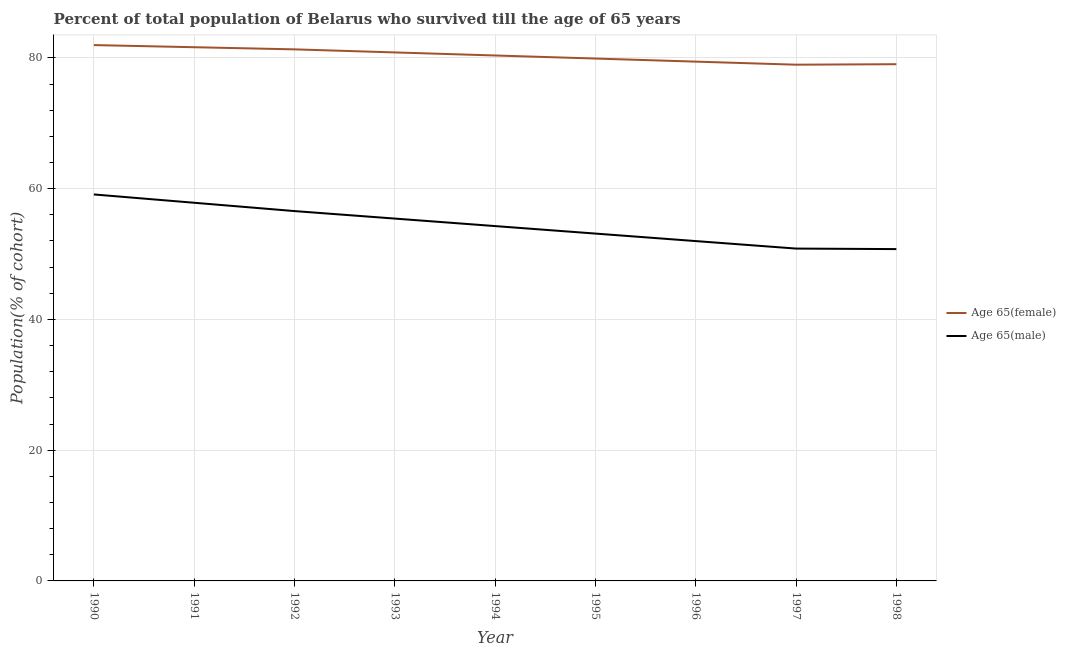How many different coloured lines are there?
Offer a terse response. 2. Does the line corresponding to percentage of female population who survived till age of 65 intersect with the line corresponding to percentage of male population who survived till age of 65?
Make the answer very short. No. Is the number of lines equal to the number of legend labels?
Offer a very short reply. Yes. What is the percentage of female population who survived till age of 65 in 1995?
Give a very brief answer. 79.9. Across all years, what is the maximum percentage of female population who survived till age of 65?
Keep it short and to the point. 81.96. Across all years, what is the minimum percentage of female population who survived till age of 65?
Offer a very short reply. 78.96. What is the total percentage of male population who survived till age of 65 in the graph?
Ensure brevity in your answer.  489.93. What is the difference between the percentage of female population who survived till age of 65 in 1995 and that in 1996?
Give a very brief answer. 0.47. What is the difference between the percentage of female population who survived till age of 65 in 1992 and the percentage of male population who survived till age of 65 in 1998?
Make the answer very short. 30.55. What is the average percentage of male population who survived till age of 65 per year?
Ensure brevity in your answer.  54.44. In the year 1996, what is the difference between the percentage of female population who survived till age of 65 and percentage of male population who survived till age of 65?
Offer a terse response. 27.45. In how many years, is the percentage of male population who survived till age of 65 greater than 24 %?
Provide a succinct answer. 9. What is the ratio of the percentage of female population who survived till age of 65 in 1995 to that in 1996?
Your answer should be very brief. 1.01. Is the percentage of female population who survived till age of 65 in 1995 less than that in 1997?
Your answer should be very brief. No. Is the difference between the percentage of female population who survived till age of 65 in 1993 and 1995 greater than the difference between the percentage of male population who survived till age of 65 in 1993 and 1995?
Keep it short and to the point. No. What is the difference between the highest and the second highest percentage of male population who survived till age of 65?
Provide a short and direct response. 1.27. What is the difference between the highest and the lowest percentage of male population who survived till age of 65?
Make the answer very short. 8.36. In how many years, is the percentage of female population who survived till age of 65 greater than the average percentage of female population who survived till age of 65 taken over all years?
Provide a succinct answer. 4. Does the graph contain grids?
Provide a short and direct response. Yes. What is the title of the graph?
Offer a terse response. Percent of total population of Belarus who survived till the age of 65 years. What is the label or title of the Y-axis?
Offer a very short reply. Population(% of cohort). What is the Population(% of cohort) in Age 65(female) in 1990?
Your response must be concise. 81.96. What is the Population(% of cohort) of Age 65(male) in 1990?
Your answer should be very brief. 59.11. What is the Population(% of cohort) of Age 65(female) in 1991?
Keep it short and to the point. 81.63. What is the Population(% of cohort) of Age 65(male) in 1991?
Provide a short and direct response. 57.84. What is the Population(% of cohort) of Age 65(female) in 1992?
Your response must be concise. 81.31. What is the Population(% of cohort) in Age 65(male) in 1992?
Offer a very short reply. 56.57. What is the Population(% of cohort) of Age 65(female) in 1993?
Ensure brevity in your answer.  80.84. What is the Population(% of cohort) of Age 65(male) in 1993?
Offer a very short reply. 55.42. What is the Population(% of cohort) in Age 65(female) in 1994?
Offer a terse response. 80.37. What is the Population(% of cohort) in Age 65(male) in 1994?
Your response must be concise. 54.28. What is the Population(% of cohort) of Age 65(female) in 1995?
Offer a very short reply. 79.9. What is the Population(% of cohort) of Age 65(male) in 1995?
Keep it short and to the point. 53.13. What is the Population(% of cohort) of Age 65(female) in 1996?
Ensure brevity in your answer.  79.43. What is the Population(% of cohort) in Age 65(male) in 1996?
Offer a very short reply. 51.98. What is the Population(% of cohort) in Age 65(female) in 1997?
Provide a short and direct response. 78.96. What is the Population(% of cohort) of Age 65(male) in 1997?
Your response must be concise. 50.83. What is the Population(% of cohort) of Age 65(female) in 1998?
Your answer should be very brief. 79.04. What is the Population(% of cohort) in Age 65(male) in 1998?
Ensure brevity in your answer.  50.76. Across all years, what is the maximum Population(% of cohort) in Age 65(female)?
Ensure brevity in your answer.  81.96. Across all years, what is the maximum Population(% of cohort) of Age 65(male)?
Provide a succinct answer. 59.11. Across all years, what is the minimum Population(% of cohort) of Age 65(female)?
Ensure brevity in your answer.  78.96. Across all years, what is the minimum Population(% of cohort) of Age 65(male)?
Provide a succinct answer. 50.76. What is the total Population(% of cohort) of Age 65(female) in the graph?
Offer a terse response. 723.43. What is the total Population(% of cohort) in Age 65(male) in the graph?
Offer a very short reply. 489.93. What is the difference between the Population(% of cohort) in Age 65(female) in 1990 and that in 1991?
Give a very brief answer. 0.33. What is the difference between the Population(% of cohort) in Age 65(male) in 1990 and that in 1991?
Keep it short and to the point. 1.27. What is the difference between the Population(% of cohort) in Age 65(female) in 1990 and that in 1992?
Your response must be concise. 0.65. What is the difference between the Population(% of cohort) in Age 65(male) in 1990 and that in 1992?
Your answer should be very brief. 2.54. What is the difference between the Population(% of cohort) in Age 65(female) in 1990 and that in 1993?
Make the answer very short. 1.12. What is the difference between the Population(% of cohort) in Age 65(male) in 1990 and that in 1993?
Your answer should be compact. 3.69. What is the difference between the Population(% of cohort) of Age 65(female) in 1990 and that in 1994?
Provide a short and direct response. 1.59. What is the difference between the Population(% of cohort) of Age 65(male) in 1990 and that in 1994?
Provide a succinct answer. 4.84. What is the difference between the Population(% of cohort) in Age 65(female) in 1990 and that in 1995?
Provide a succinct answer. 2.06. What is the difference between the Population(% of cohort) in Age 65(male) in 1990 and that in 1995?
Provide a short and direct response. 5.99. What is the difference between the Population(% of cohort) in Age 65(female) in 1990 and that in 1996?
Provide a short and direct response. 2.53. What is the difference between the Population(% of cohort) of Age 65(male) in 1990 and that in 1996?
Keep it short and to the point. 7.13. What is the difference between the Population(% of cohort) of Age 65(female) in 1990 and that in 1997?
Give a very brief answer. 3. What is the difference between the Population(% of cohort) of Age 65(male) in 1990 and that in 1997?
Your answer should be very brief. 8.28. What is the difference between the Population(% of cohort) in Age 65(female) in 1990 and that in 1998?
Provide a short and direct response. 2.93. What is the difference between the Population(% of cohort) in Age 65(male) in 1990 and that in 1998?
Offer a very short reply. 8.36. What is the difference between the Population(% of cohort) in Age 65(female) in 1991 and that in 1992?
Provide a succinct answer. 0.33. What is the difference between the Population(% of cohort) of Age 65(male) in 1991 and that in 1992?
Offer a terse response. 1.27. What is the difference between the Population(% of cohort) in Age 65(female) in 1991 and that in 1993?
Make the answer very short. 0.8. What is the difference between the Population(% of cohort) of Age 65(male) in 1991 and that in 1993?
Provide a succinct answer. 2.42. What is the difference between the Population(% of cohort) in Age 65(female) in 1991 and that in 1994?
Your response must be concise. 1.27. What is the difference between the Population(% of cohort) in Age 65(male) in 1991 and that in 1994?
Ensure brevity in your answer.  3.57. What is the difference between the Population(% of cohort) in Age 65(female) in 1991 and that in 1995?
Keep it short and to the point. 1.73. What is the difference between the Population(% of cohort) in Age 65(male) in 1991 and that in 1995?
Provide a succinct answer. 4.71. What is the difference between the Population(% of cohort) of Age 65(female) in 1991 and that in 1996?
Provide a succinct answer. 2.2. What is the difference between the Population(% of cohort) in Age 65(male) in 1991 and that in 1996?
Your response must be concise. 5.86. What is the difference between the Population(% of cohort) in Age 65(female) in 1991 and that in 1997?
Ensure brevity in your answer.  2.67. What is the difference between the Population(% of cohort) of Age 65(male) in 1991 and that in 1997?
Give a very brief answer. 7.01. What is the difference between the Population(% of cohort) in Age 65(female) in 1991 and that in 1998?
Give a very brief answer. 2.6. What is the difference between the Population(% of cohort) in Age 65(male) in 1991 and that in 1998?
Your response must be concise. 7.09. What is the difference between the Population(% of cohort) of Age 65(female) in 1992 and that in 1993?
Offer a very short reply. 0.47. What is the difference between the Population(% of cohort) of Age 65(male) in 1992 and that in 1993?
Offer a very short reply. 1.15. What is the difference between the Population(% of cohort) of Age 65(female) in 1992 and that in 1994?
Offer a very short reply. 0.94. What is the difference between the Population(% of cohort) in Age 65(male) in 1992 and that in 1994?
Ensure brevity in your answer.  2.29. What is the difference between the Population(% of cohort) of Age 65(female) in 1992 and that in 1995?
Give a very brief answer. 1.41. What is the difference between the Population(% of cohort) in Age 65(male) in 1992 and that in 1995?
Provide a short and direct response. 3.44. What is the difference between the Population(% of cohort) in Age 65(female) in 1992 and that in 1996?
Your answer should be compact. 1.88. What is the difference between the Population(% of cohort) of Age 65(male) in 1992 and that in 1996?
Give a very brief answer. 4.59. What is the difference between the Population(% of cohort) of Age 65(female) in 1992 and that in 1997?
Provide a short and direct response. 2.34. What is the difference between the Population(% of cohort) in Age 65(male) in 1992 and that in 1997?
Provide a short and direct response. 5.74. What is the difference between the Population(% of cohort) in Age 65(female) in 1992 and that in 1998?
Give a very brief answer. 2.27. What is the difference between the Population(% of cohort) of Age 65(male) in 1992 and that in 1998?
Ensure brevity in your answer.  5.81. What is the difference between the Population(% of cohort) in Age 65(female) in 1993 and that in 1994?
Offer a very short reply. 0.47. What is the difference between the Population(% of cohort) of Age 65(male) in 1993 and that in 1994?
Your response must be concise. 1.15. What is the difference between the Population(% of cohort) of Age 65(female) in 1993 and that in 1995?
Offer a terse response. 0.94. What is the difference between the Population(% of cohort) in Age 65(male) in 1993 and that in 1995?
Keep it short and to the point. 2.29. What is the difference between the Population(% of cohort) of Age 65(female) in 1993 and that in 1996?
Provide a short and direct response. 1.41. What is the difference between the Population(% of cohort) of Age 65(male) in 1993 and that in 1996?
Your response must be concise. 3.44. What is the difference between the Population(% of cohort) in Age 65(female) in 1993 and that in 1997?
Your response must be concise. 1.88. What is the difference between the Population(% of cohort) in Age 65(male) in 1993 and that in 1997?
Your response must be concise. 4.59. What is the difference between the Population(% of cohort) of Age 65(female) in 1993 and that in 1998?
Offer a very short reply. 1.8. What is the difference between the Population(% of cohort) in Age 65(male) in 1993 and that in 1998?
Your answer should be compact. 4.67. What is the difference between the Population(% of cohort) in Age 65(female) in 1994 and that in 1995?
Provide a short and direct response. 0.47. What is the difference between the Population(% of cohort) in Age 65(male) in 1994 and that in 1995?
Your response must be concise. 1.15. What is the difference between the Population(% of cohort) of Age 65(female) in 1994 and that in 1996?
Keep it short and to the point. 0.94. What is the difference between the Population(% of cohort) of Age 65(male) in 1994 and that in 1996?
Provide a short and direct response. 2.29. What is the difference between the Population(% of cohort) in Age 65(female) in 1994 and that in 1997?
Offer a terse response. 1.41. What is the difference between the Population(% of cohort) of Age 65(male) in 1994 and that in 1997?
Provide a short and direct response. 3.44. What is the difference between the Population(% of cohort) in Age 65(female) in 1994 and that in 1998?
Give a very brief answer. 1.33. What is the difference between the Population(% of cohort) of Age 65(male) in 1994 and that in 1998?
Keep it short and to the point. 3.52. What is the difference between the Population(% of cohort) in Age 65(female) in 1995 and that in 1996?
Provide a short and direct response. 0.47. What is the difference between the Population(% of cohort) of Age 65(male) in 1995 and that in 1996?
Your answer should be compact. 1.15. What is the difference between the Population(% of cohort) in Age 65(female) in 1995 and that in 1997?
Provide a short and direct response. 0.94. What is the difference between the Population(% of cohort) of Age 65(male) in 1995 and that in 1997?
Ensure brevity in your answer.  2.29. What is the difference between the Population(% of cohort) of Age 65(female) in 1995 and that in 1998?
Give a very brief answer. 0.86. What is the difference between the Population(% of cohort) in Age 65(male) in 1995 and that in 1998?
Provide a succinct answer. 2.37. What is the difference between the Population(% of cohort) of Age 65(female) in 1996 and that in 1997?
Offer a terse response. 0.47. What is the difference between the Population(% of cohort) in Age 65(male) in 1996 and that in 1997?
Ensure brevity in your answer.  1.15. What is the difference between the Population(% of cohort) of Age 65(female) in 1996 and that in 1998?
Make the answer very short. 0.4. What is the difference between the Population(% of cohort) in Age 65(male) in 1996 and that in 1998?
Make the answer very short. 1.23. What is the difference between the Population(% of cohort) of Age 65(female) in 1997 and that in 1998?
Provide a succinct answer. -0.07. What is the difference between the Population(% of cohort) of Age 65(male) in 1997 and that in 1998?
Provide a succinct answer. 0.08. What is the difference between the Population(% of cohort) in Age 65(female) in 1990 and the Population(% of cohort) in Age 65(male) in 1991?
Offer a very short reply. 24.12. What is the difference between the Population(% of cohort) in Age 65(female) in 1990 and the Population(% of cohort) in Age 65(male) in 1992?
Ensure brevity in your answer.  25.39. What is the difference between the Population(% of cohort) of Age 65(female) in 1990 and the Population(% of cohort) of Age 65(male) in 1993?
Provide a short and direct response. 26.54. What is the difference between the Population(% of cohort) of Age 65(female) in 1990 and the Population(% of cohort) of Age 65(male) in 1994?
Offer a very short reply. 27.69. What is the difference between the Population(% of cohort) of Age 65(female) in 1990 and the Population(% of cohort) of Age 65(male) in 1995?
Offer a terse response. 28.83. What is the difference between the Population(% of cohort) in Age 65(female) in 1990 and the Population(% of cohort) in Age 65(male) in 1996?
Your answer should be compact. 29.98. What is the difference between the Population(% of cohort) in Age 65(female) in 1990 and the Population(% of cohort) in Age 65(male) in 1997?
Your response must be concise. 31.13. What is the difference between the Population(% of cohort) in Age 65(female) in 1990 and the Population(% of cohort) in Age 65(male) in 1998?
Make the answer very short. 31.21. What is the difference between the Population(% of cohort) of Age 65(female) in 1991 and the Population(% of cohort) of Age 65(male) in 1992?
Your response must be concise. 25.06. What is the difference between the Population(% of cohort) in Age 65(female) in 1991 and the Population(% of cohort) in Age 65(male) in 1993?
Provide a succinct answer. 26.21. What is the difference between the Population(% of cohort) of Age 65(female) in 1991 and the Population(% of cohort) of Age 65(male) in 1994?
Offer a very short reply. 27.36. What is the difference between the Population(% of cohort) of Age 65(female) in 1991 and the Population(% of cohort) of Age 65(male) in 1995?
Keep it short and to the point. 28.5. What is the difference between the Population(% of cohort) of Age 65(female) in 1991 and the Population(% of cohort) of Age 65(male) in 1996?
Give a very brief answer. 29.65. What is the difference between the Population(% of cohort) of Age 65(female) in 1991 and the Population(% of cohort) of Age 65(male) in 1997?
Make the answer very short. 30.8. What is the difference between the Population(% of cohort) in Age 65(female) in 1991 and the Population(% of cohort) in Age 65(male) in 1998?
Make the answer very short. 30.88. What is the difference between the Population(% of cohort) of Age 65(female) in 1992 and the Population(% of cohort) of Age 65(male) in 1993?
Give a very brief answer. 25.88. What is the difference between the Population(% of cohort) of Age 65(female) in 1992 and the Population(% of cohort) of Age 65(male) in 1994?
Keep it short and to the point. 27.03. What is the difference between the Population(% of cohort) in Age 65(female) in 1992 and the Population(% of cohort) in Age 65(male) in 1995?
Your answer should be compact. 28.18. What is the difference between the Population(% of cohort) in Age 65(female) in 1992 and the Population(% of cohort) in Age 65(male) in 1996?
Give a very brief answer. 29.32. What is the difference between the Population(% of cohort) in Age 65(female) in 1992 and the Population(% of cohort) in Age 65(male) in 1997?
Your response must be concise. 30.47. What is the difference between the Population(% of cohort) in Age 65(female) in 1992 and the Population(% of cohort) in Age 65(male) in 1998?
Ensure brevity in your answer.  30.55. What is the difference between the Population(% of cohort) of Age 65(female) in 1993 and the Population(% of cohort) of Age 65(male) in 1994?
Offer a terse response. 26.56. What is the difference between the Population(% of cohort) in Age 65(female) in 1993 and the Population(% of cohort) in Age 65(male) in 1995?
Offer a terse response. 27.71. What is the difference between the Population(% of cohort) in Age 65(female) in 1993 and the Population(% of cohort) in Age 65(male) in 1996?
Make the answer very short. 28.86. What is the difference between the Population(% of cohort) of Age 65(female) in 1993 and the Population(% of cohort) of Age 65(male) in 1997?
Provide a succinct answer. 30. What is the difference between the Population(% of cohort) of Age 65(female) in 1993 and the Population(% of cohort) of Age 65(male) in 1998?
Your answer should be compact. 30.08. What is the difference between the Population(% of cohort) of Age 65(female) in 1994 and the Population(% of cohort) of Age 65(male) in 1995?
Offer a terse response. 27.24. What is the difference between the Population(% of cohort) in Age 65(female) in 1994 and the Population(% of cohort) in Age 65(male) in 1996?
Ensure brevity in your answer.  28.39. What is the difference between the Population(% of cohort) in Age 65(female) in 1994 and the Population(% of cohort) in Age 65(male) in 1997?
Give a very brief answer. 29.53. What is the difference between the Population(% of cohort) in Age 65(female) in 1994 and the Population(% of cohort) in Age 65(male) in 1998?
Provide a succinct answer. 29.61. What is the difference between the Population(% of cohort) in Age 65(female) in 1995 and the Population(% of cohort) in Age 65(male) in 1996?
Provide a short and direct response. 27.92. What is the difference between the Population(% of cohort) of Age 65(female) in 1995 and the Population(% of cohort) of Age 65(male) in 1997?
Offer a very short reply. 29.06. What is the difference between the Population(% of cohort) in Age 65(female) in 1995 and the Population(% of cohort) in Age 65(male) in 1998?
Your answer should be compact. 29.14. What is the difference between the Population(% of cohort) in Age 65(female) in 1996 and the Population(% of cohort) in Age 65(male) in 1997?
Make the answer very short. 28.6. What is the difference between the Population(% of cohort) in Age 65(female) in 1996 and the Population(% of cohort) in Age 65(male) in 1998?
Give a very brief answer. 28.68. What is the difference between the Population(% of cohort) in Age 65(female) in 1997 and the Population(% of cohort) in Age 65(male) in 1998?
Provide a short and direct response. 28.21. What is the average Population(% of cohort) in Age 65(female) per year?
Keep it short and to the point. 80.38. What is the average Population(% of cohort) of Age 65(male) per year?
Ensure brevity in your answer.  54.44. In the year 1990, what is the difference between the Population(% of cohort) in Age 65(female) and Population(% of cohort) in Age 65(male)?
Give a very brief answer. 22.85. In the year 1991, what is the difference between the Population(% of cohort) of Age 65(female) and Population(% of cohort) of Age 65(male)?
Make the answer very short. 23.79. In the year 1992, what is the difference between the Population(% of cohort) in Age 65(female) and Population(% of cohort) in Age 65(male)?
Provide a succinct answer. 24.74. In the year 1993, what is the difference between the Population(% of cohort) in Age 65(female) and Population(% of cohort) in Age 65(male)?
Ensure brevity in your answer.  25.41. In the year 1994, what is the difference between the Population(% of cohort) in Age 65(female) and Population(% of cohort) in Age 65(male)?
Your answer should be compact. 26.09. In the year 1995, what is the difference between the Population(% of cohort) of Age 65(female) and Population(% of cohort) of Age 65(male)?
Offer a very short reply. 26.77. In the year 1996, what is the difference between the Population(% of cohort) of Age 65(female) and Population(% of cohort) of Age 65(male)?
Your answer should be compact. 27.45. In the year 1997, what is the difference between the Population(% of cohort) in Age 65(female) and Population(% of cohort) in Age 65(male)?
Provide a succinct answer. 28.13. In the year 1998, what is the difference between the Population(% of cohort) of Age 65(female) and Population(% of cohort) of Age 65(male)?
Make the answer very short. 28.28. What is the ratio of the Population(% of cohort) of Age 65(female) in 1990 to that in 1991?
Your answer should be very brief. 1. What is the ratio of the Population(% of cohort) in Age 65(female) in 1990 to that in 1992?
Make the answer very short. 1.01. What is the ratio of the Population(% of cohort) of Age 65(male) in 1990 to that in 1992?
Make the answer very short. 1.04. What is the ratio of the Population(% of cohort) of Age 65(female) in 1990 to that in 1993?
Ensure brevity in your answer.  1.01. What is the ratio of the Population(% of cohort) of Age 65(male) in 1990 to that in 1993?
Keep it short and to the point. 1.07. What is the ratio of the Population(% of cohort) in Age 65(female) in 1990 to that in 1994?
Ensure brevity in your answer.  1.02. What is the ratio of the Population(% of cohort) of Age 65(male) in 1990 to that in 1994?
Offer a terse response. 1.09. What is the ratio of the Population(% of cohort) of Age 65(female) in 1990 to that in 1995?
Give a very brief answer. 1.03. What is the ratio of the Population(% of cohort) in Age 65(male) in 1990 to that in 1995?
Offer a terse response. 1.11. What is the ratio of the Population(% of cohort) of Age 65(female) in 1990 to that in 1996?
Give a very brief answer. 1.03. What is the ratio of the Population(% of cohort) in Age 65(male) in 1990 to that in 1996?
Offer a very short reply. 1.14. What is the ratio of the Population(% of cohort) of Age 65(female) in 1990 to that in 1997?
Make the answer very short. 1.04. What is the ratio of the Population(% of cohort) in Age 65(male) in 1990 to that in 1997?
Ensure brevity in your answer.  1.16. What is the ratio of the Population(% of cohort) in Age 65(female) in 1990 to that in 1998?
Provide a succinct answer. 1.04. What is the ratio of the Population(% of cohort) in Age 65(male) in 1990 to that in 1998?
Your answer should be very brief. 1.16. What is the ratio of the Population(% of cohort) of Age 65(male) in 1991 to that in 1992?
Ensure brevity in your answer.  1.02. What is the ratio of the Population(% of cohort) of Age 65(female) in 1991 to that in 1993?
Your answer should be compact. 1.01. What is the ratio of the Population(% of cohort) in Age 65(male) in 1991 to that in 1993?
Provide a short and direct response. 1.04. What is the ratio of the Population(% of cohort) of Age 65(female) in 1991 to that in 1994?
Your response must be concise. 1.02. What is the ratio of the Population(% of cohort) in Age 65(male) in 1991 to that in 1994?
Offer a very short reply. 1.07. What is the ratio of the Population(% of cohort) of Age 65(female) in 1991 to that in 1995?
Keep it short and to the point. 1.02. What is the ratio of the Population(% of cohort) in Age 65(male) in 1991 to that in 1995?
Your answer should be compact. 1.09. What is the ratio of the Population(% of cohort) of Age 65(female) in 1991 to that in 1996?
Ensure brevity in your answer.  1.03. What is the ratio of the Population(% of cohort) in Age 65(male) in 1991 to that in 1996?
Offer a very short reply. 1.11. What is the ratio of the Population(% of cohort) of Age 65(female) in 1991 to that in 1997?
Your answer should be compact. 1.03. What is the ratio of the Population(% of cohort) in Age 65(male) in 1991 to that in 1997?
Make the answer very short. 1.14. What is the ratio of the Population(% of cohort) of Age 65(female) in 1991 to that in 1998?
Your response must be concise. 1.03. What is the ratio of the Population(% of cohort) in Age 65(male) in 1991 to that in 1998?
Your answer should be compact. 1.14. What is the ratio of the Population(% of cohort) of Age 65(female) in 1992 to that in 1993?
Ensure brevity in your answer.  1.01. What is the ratio of the Population(% of cohort) in Age 65(male) in 1992 to that in 1993?
Give a very brief answer. 1.02. What is the ratio of the Population(% of cohort) of Age 65(female) in 1992 to that in 1994?
Provide a short and direct response. 1.01. What is the ratio of the Population(% of cohort) in Age 65(male) in 1992 to that in 1994?
Your answer should be very brief. 1.04. What is the ratio of the Population(% of cohort) of Age 65(female) in 1992 to that in 1995?
Your answer should be compact. 1.02. What is the ratio of the Population(% of cohort) in Age 65(male) in 1992 to that in 1995?
Provide a short and direct response. 1.06. What is the ratio of the Population(% of cohort) in Age 65(female) in 1992 to that in 1996?
Offer a terse response. 1.02. What is the ratio of the Population(% of cohort) of Age 65(male) in 1992 to that in 1996?
Ensure brevity in your answer.  1.09. What is the ratio of the Population(% of cohort) in Age 65(female) in 1992 to that in 1997?
Ensure brevity in your answer.  1.03. What is the ratio of the Population(% of cohort) in Age 65(male) in 1992 to that in 1997?
Your answer should be very brief. 1.11. What is the ratio of the Population(% of cohort) in Age 65(female) in 1992 to that in 1998?
Make the answer very short. 1.03. What is the ratio of the Population(% of cohort) of Age 65(male) in 1992 to that in 1998?
Your answer should be compact. 1.11. What is the ratio of the Population(% of cohort) in Age 65(female) in 1993 to that in 1994?
Your response must be concise. 1.01. What is the ratio of the Population(% of cohort) of Age 65(male) in 1993 to that in 1994?
Make the answer very short. 1.02. What is the ratio of the Population(% of cohort) of Age 65(female) in 1993 to that in 1995?
Keep it short and to the point. 1.01. What is the ratio of the Population(% of cohort) of Age 65(male) in 1993 to that in 1995?
Your answer should be very brief. 1.04. What is the ratio of the Population(% of cohort) of Age 65(female) in 1993 to that in 1996?
Keep it short and to the point. 1.02. What is the ratio of the Population(% of cohort) in Age 65(male) in 1993 to that in 1996?
Offer a terse response. 1.07. What is the ratio of the Population(% of cohort) in Age 65(female) in 1993 to that in 1997?
Offer a terse response. 1.02. What is the ratio of the Population(% of cohort) of Age 65(male) in 1993 to that in 1997?
Give a very brief answer. 1.09. What is the ratio of the Population(% of cohort) in Age 65(female) in 1993 to that in 1998?
Provide a succinct answer. 1.02. What is the ratio of the Population(% of cohort) of Age 65(male) in 1993 to that in 1998?
Make the answer very short. 1.09. What is the ratio of the Population(% of cohort) in Age 65(female) in 1994 to that in 1995?
Offer a terse response. 1.01. What is the ratio of the Population(% of cohort) of Age 65(male) in 1994 to that in 1995?
Provide a succinct answer. 1.02. What is the ratio of the Population(% of cohort) in Age 65(female) in 1994 to that in 1996?
Your answer should be compact. 1.01. What is the ratio of the Population(% of cohort) in Age 65(male) in 1994 to that in 1996?
Ensure brevity in your answer.  1.04. What is the ratio of the Population(% of cohort) of Age 65(female) in 1994 to that in 1997?
Ensure brevity in your answer.  1.02. What is the ratio of the Population(% of cohort) in Age 65(male) in 1994 to that in 1997?
Keep it short and to the point. 1.07. What is the ratio of the Population(% of cohort) in Age 65(female) in 1994 to that in 1998?
Ensure brevity in your answer.  1.02. What is the ratio of the Population(% of cohort) of Age 65(male) in 1994 to that in 1998?
Provide a succinct answer. 1.07. What is the ratio of the Population(% of cohort) of Age 65(female) in 1995 to that in 1996?
Your answer should be very brief. 1.01. What is the ratio of the Population(% of cohort) in Age 65(male) in 1995 to that in 1996?
Make the answer very short. 1.02. What is the ratio of the Population(% of cohort) of Age 65(female) in 1995 to that in 1997?
Make the answer very short. 1.01. What is the ratio of the Population(% of cohort) of Age 65(male) in 1995 to that in 1997?
Keep it short and to the point. 1.05. What is the ratio of the Population(% of cohort) of Age 65(female) in 1995 to that in 1998?
Your response must be concise. 1.01. What is the ratio of the Population(% of cohort) in Age 65(male) in 1995 to that in 1998?
Provide a succinct answer. 1.05. What is the ratio of the Population(% of cohort) in Age 65(female) in 1996 to that in 1997?
Give a very brief answer. 1.01. What is the ratio of the Population(% of cohort) of Age 65(male) in 1996 to that in 1997?
Provide a short and direct response. 1.02. What is the ratio of the Population(% of cohort) in Age 65(female) in 1996 to that in 1998?
Your answer should be very brief. 1. What is the ratio of the Population(% of cohort) in Age 65(male) in 1996 to that in 1998?
Ensure brevity in your answer.  1.02. What is the difference between the highest and the second highest Population(% of cohort) in Age 65(female)?
Give a very brief answer. 0.33. What is the difference between the highest and the second highest Population(% of cohort) of Age 65(male)?
Provide a short and direct response. 1.27. What is the difference between the highest and the lowest Population(% of cohort) in Age 65(female)?
Keep it short and to the point. 3. What is the difference between the highest and the lowest Population(% of cohort) of Age 65(male)?
Give a very brief answer. 8.36. 